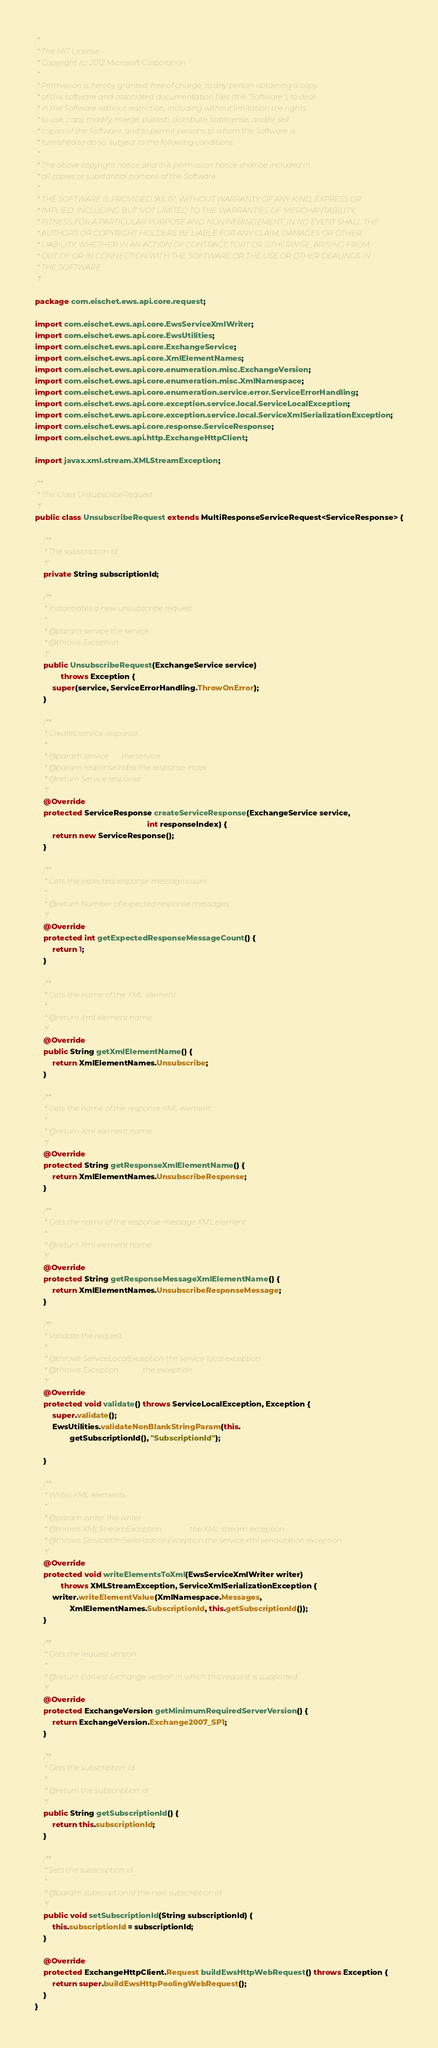Convert code to text. <code><loc_0><loc_0><loc_500><loc_500><_Java_>/*
 * The MIT License
 * Copyright (c) 2012 Microsoft Corporation
 *
 * Permission is hereby granted, free of charge, to any person obtaining a copy
 * of this software and associated documentation files (the "Software"), to deal
 * in the Software without restriction, including without limitation the rights
 * to use, copy, modify, merge, publish, distribute, sublicense, and/or sell
 * copies of the Software, and to permit persons to whom the Software is
 * furnished to do so, subject to the following conditions:
 *
 * The above copyright notice and this permission notice shall be included in
 * all copies or substantial portions of the Software.
 *
 * THE SOFTWARE IS PROVIDED "AS IS", WITHOUT WARRANTY OF ANY KIND, EXPRESS OR
 * IMPLIED, INCLUDING BUT NOT LIMITED TO THE WARRANTIES OF MERCHANTABILITY,
 * FITNESS FOR A PARTICULAR PURPOSE AND NONINFRINGEMENT. IN NO EVENT SHALL THE
 * AUTHORS OR COPYRIGHT HOLDERS BE LIABLE FOR ANY CLAIM, DAMAGES OR OTHER
 * LIABILITY, WHETHER IN AN ACTION OF CONTRACT, TORT OR OTHERWISE, ARISING FROM,
 * OUT OF OR IN CONNECTION WITH THE SOFTWARE OR THE USE OR OTHER DEALINGS IN
 * THE SOFTWARE.
 */

package com.eischet.ews.api.core.request;

import com.eischet.ews.api.core.EwsServiceXmlWriter;
import com.eischet.ews.api.core.EwsUtilities;
import com.eischet.ews.api.core.ExchangeService;
import com.eischet.ews.api.core.XmlElementNames;
import com.eischet.ews.api.core.enumeration.misc.ExchangeVersion;
import com.eischet.ews.api.core.enumeration.misc.XmlNamespace;
import com.eischet.ews.api.core.enumeration.service.error.ServiceErrorHandling;
import com.eischet.ews.api.core.exception.service.local.ServiceLocalException;
import com.eischet.ews.api.core.exception.service.local.ServiceXmlSerializationException;
import com.eischet.ews.api.core.response.ServiceResponse;
import com.eischet.ews.api.http.ExchangeHttpClient;

import javax.xml.stream.XMLStreamException;

/**
 * The Class UnsubscribeRequest.
 */
public class UnsubscribeRequest extends MultiResponseServiceRequest<ServiceResponse> {

    /**
     * The subscription id.
     */
    private String subscriptionId;

    /**
     * Instantiates a new unsubscribe request.
     *
     * @param service the service
     * @throws Exception
     */
    public UnsubscribeRequest(ExchangeService service)
            throws Exception {
        super(service, ServiceErrorHandling.ThrowOnError);
    }

    /**
     * Creates service response.
     *
     * @param service       the service
     * @param responseIndex the response index
     * @return Service response.
     */
    @Override
    protected ServiceResponse createServiceResponse(ExchangeService service,
                                                    int responseIndex) {
        return new ServiceResponse();
    }

    /**
     * Gets the expected response message count.
     *
     * @return Number of expected response messages.
     */
    @Override
    protected int getExpectedResponseMessageCount() {
        return 1;
    }

    /**
     * Gets the name of the XML element.
     *
     * @return Xml element name.
     */
    @Override
    public String getXmlElementName() {
        return XmlElementNames.Unsubscribe;
    }

    /**
     * Gets the name of the response XML element.
     *
     * @return Xml element name.
     */
    @Override
    protected String getResponseXmlElementName() {
        return XmlElementNames.UnsubscribeResponse;
    }

    /**
     * Gets the name of the response message XML element.
     *
     * @return Xml element name.
     */
    @Override
    protected String getResponseMessageXmlElementName() {
        return XmlElementNames.UnsubscribeResponseMessage;
    }

    /**
     * Validate the request.
     *
     * @throws ServiceLocalException the service local exception
     * @throws Exception             the exception
     */
    @Override
    protected void validate() throws ServiceLocalException, Exception {
        super.validate();
        EwsUtilities.validateNonBlankStringParam(this.
                getSubscriptionId(), "SubscriptionId");

    }

    /**
     * Writes XML elements.
     *
     * @param writer the writer
     * @throws XMLStreamException               the XML stream exception
     * @throws ServiceXmlSerializationException the service xml serialization exception
     */
    @Override
    protected void writeElementsToXml(EwsServiceXmlWriter writer)
            throws XMLStreamException, ServiceXmlSerializationException {
        writer.writeElementValue(XmlNamespace.Messages,
                XmlElementNames.SubscriptionId, this.getSubscriptionId());
    }

    /**
     * Gets the request version.
     *
     * @return Earliest Exchange version in which this request is supported.
     */
    @Override
    protected ExchangeVersion getMinimumRequiredServerVersion() {
        return ExchangeVersion.Exchange2007_SP1;
    }

    /**
     * Gets the subscription id.
     *
     * @return the subscription id
     */
    public String getSubscriptionId() {
        return this.subscriptionId;
    }

    /**
     * Sets the subscription id.
     *
     * @param subscriptionId the new subscription id
     */
    public void setSubscriptionId(String subscriptionId) {
        this.subscriptionId = subscriptionId;
    }

    @Override
    protected ExchangeHttpClient.Request buildEwsHttpWebRequest() throws Exception {
        return super.buildEwsHttpPoolingWebRequest();
    }
}
</code> 